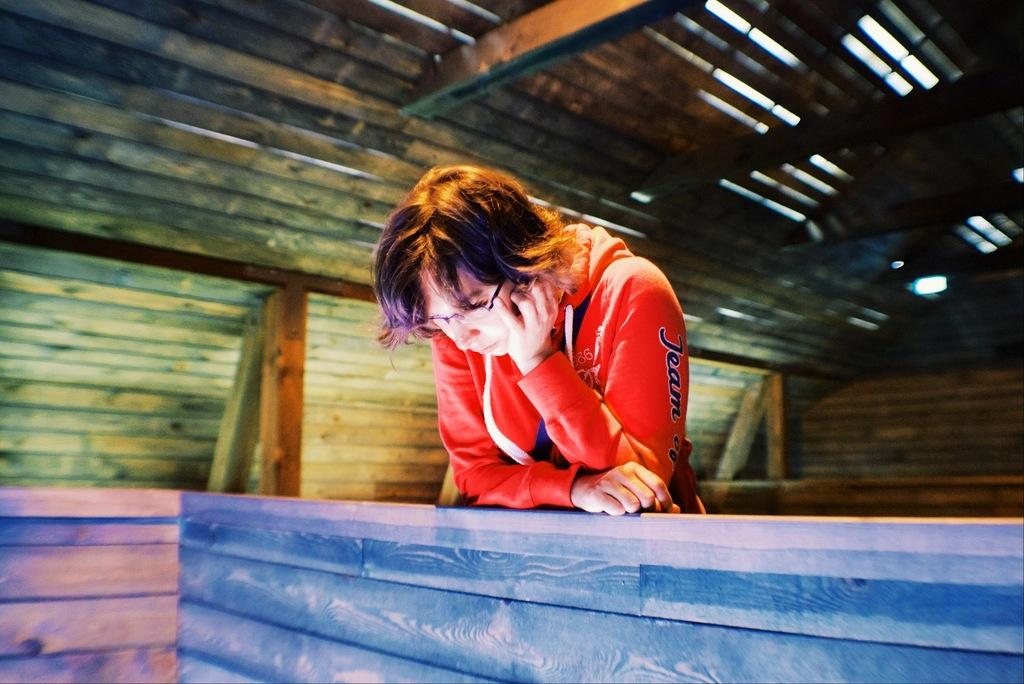What can be seen in the image? There is a person in the image. Can you describe the person's appearance? The person is wearing glasses. What is visible in the background of the image? There is a wall and wooden poles in the background of the image. What is the top of the image showing? The top of the image contains a roof. What type of noise can be heard coming from the person's dad in the image? There is no dad present in the image, so it's not possible to determine what, if any, noise might be heard. 